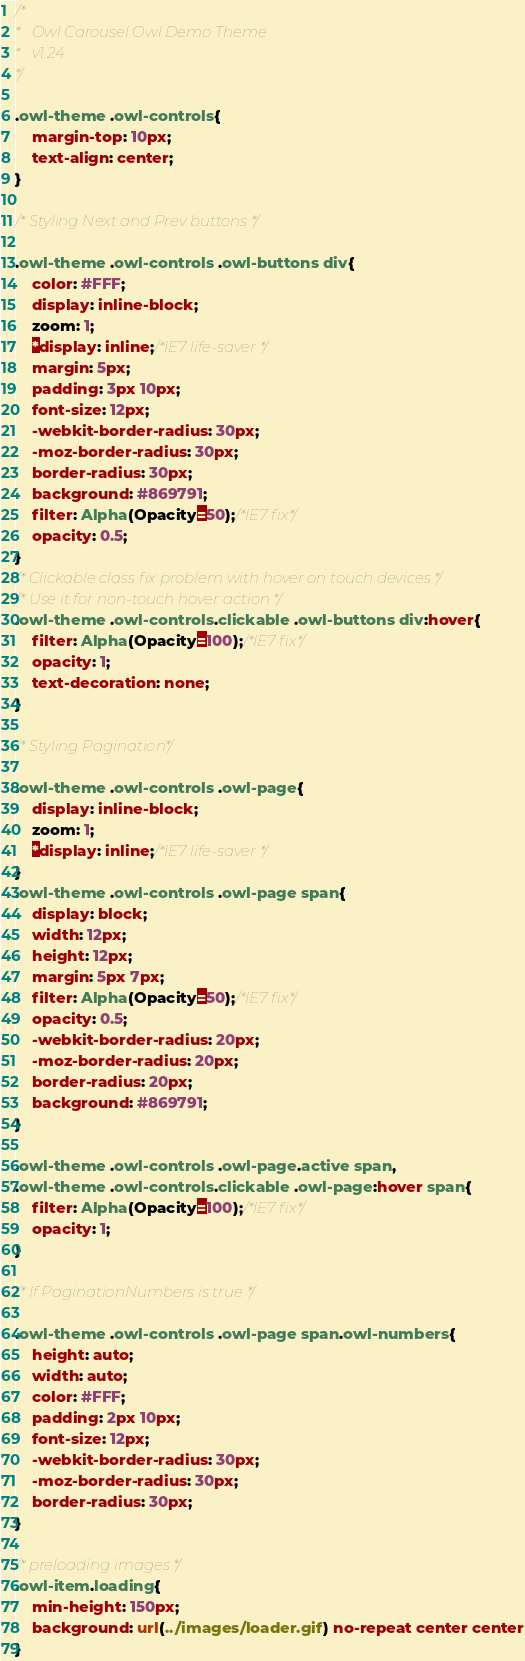<code> <loc_0><loc_0><loc_500><loc_500><_CSS_>/*
* 	Owl Carousel Owl Demo Theme 
*	v1.24
*/

.owl-theme .owl-controls{
	margin-top: 10px;
	text-align: center;
}

/* Styling Next and Prev buttons */

.owl-theme .owl-controls .owl-buttons div{
	color: #FFF;
	display: inline-block;
	zoom: 1;
	*display: inline;/*IE7 life-saver */
	margin: 5px;
	padding: 3px 10px;
	font-size: 12px;
	-webkit-border-radius: 30px;
	-moz-border-radius: 30px;
	border-radius: 30px;
	background: #869791;
	filter: Alpha(Opacity=50);/*IE7 fix*/
	opacity: 0.5;
}
/* Clickable class fix problem with hover on touch devices */
/* Use it for non-touch hover action */
.owl-theme .owl-controls.clickable .owl-buttons div:hover{
	filter: Alpha(Opacity=100);/*IE7 fix*/
	opacity: 1;
	text-decoration: none;
}

/* Styling Pagination*/

.owl-theme .owl-controls .owl-page{
	display: inline-block;
	zoom: 1;
	*display: inline;/*IE7 life-saver */
}
.owl-theme .owl-controls .owl-page span{
	display: block;
	width: 12px;
	height: 12px;
	margin: 5px 7px;
	filter: Alpha(Opacity=50);/*IE7 fix*/
	opacity: 0.5;
	-webkit-border-radius: 20px;
	-moz-border-radius: 20px;
	border-radius: 20px;
	background: #869791;
}

.owl-theme .owl-controls .owl-page.active span,
.owl-theme .owl-controls.clickable .owl-page:hover span{
	filter: Alpha(Opacity=100);/*IE7 fix*/
	opacity: 1;
}

/* If PaginationNumbers is true */

.owl-theme .owl-controls .owl-page span.owl-numbers{
	height: auto;
	width: auto;
	color: #FFF;
	padding: 2px 10px;
	font-size: 12px;
	-webkit-border-radius: 30px;
	-moz-border-radius: 30px;
	border-radius: 30px;
}

/* preloading images */
.owl-item.loading{
	min-height: 150px;
	background: url(../images/loader.gif) no-repeat center center
}</code> 